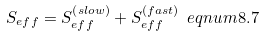Convert formula to latex. <formula><loc_0><loc_0><loc_500><loc_500>S _ { e f f } = S _ { e f f } ^ { \left ( s l o w \right ) } + S _ { e f f } ^ { \left ( f a s t \right ) } \ e q n u m { 8 . 7 }</formula> 